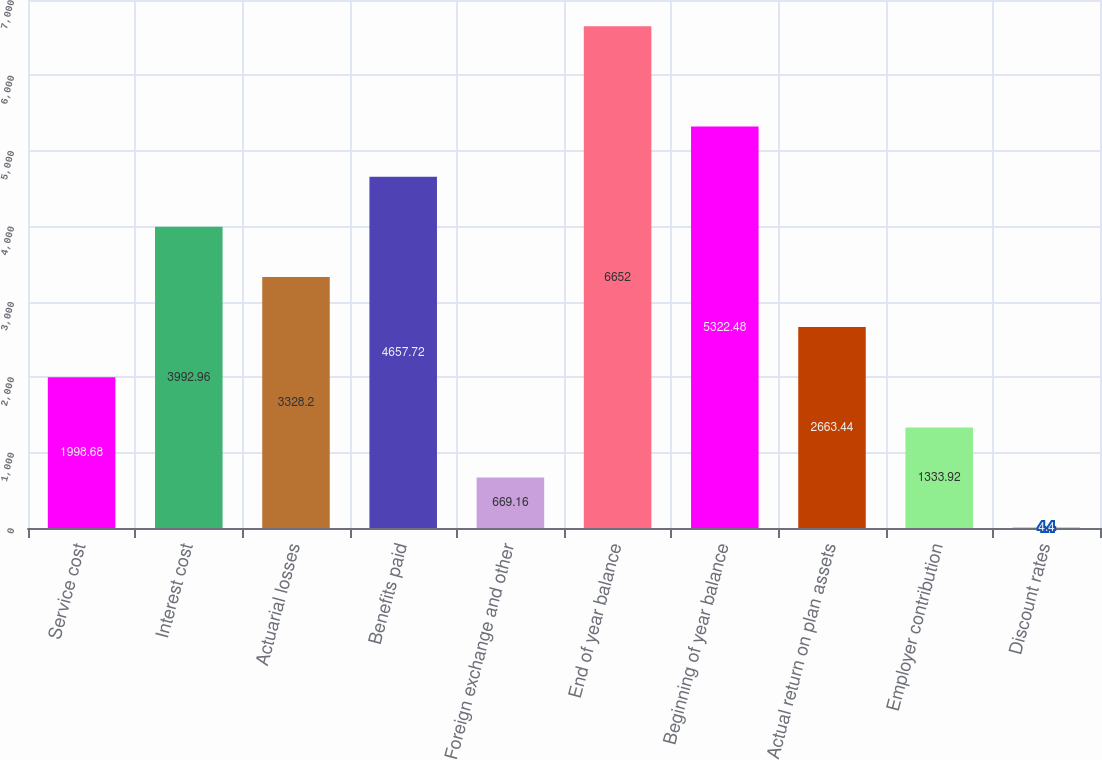Convert chart. <chart><loc_0><loc_0><loc_500><loc_500><bar_chart><fcel>Service cost<fcel>Interest cost<fcel>Actuarial losses<fcel>Benefits paid<fcel>Foreign exchange and other<fcel>End of year balance<fcel>Beginning of year balance<fcel>Actual return on plan assets<fcel>Employer contribution<fcel>Discount rates<nl><fcel>1998.68<fcel>3992.96<fcel>3328.2<fcel>4657.72<fcel>669.16<fcel>6652<fcel>5322.48<fcel>2663.44<fcel>1333.92<fcel>4.4<nl></chart> 